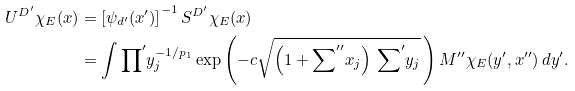Convert formula to latex. <formula><loc_0><loc_0><loc_500><loc_500>U ^ { D ^ { \prime } } \chi _ { E } ( x ) & = \left [ \psi _ { d ^ { \prime } } ( x ^ { \prime } ) \right ] ^ { - 1 } S ^ { D ^ { \prime } } \chi _ { E } ( x ) \\ & = \int { \prod } ^ { \prime } y _ { j } ^ { - 1 \slash p _ { 1 } } \exp \left ( - c \sqrt { \left ( 1 + { \sum } ^ { \prime \prime } x _ { j } \right ) \, { \sum } ^ { \prime } y _ { j } } \, \right ) M ^ { \prime \prime } \chi _ { E } ( y ^ { \prime } , x ^ { \prime \prime } ) \, d y ^ { \prime } .</formula> 